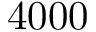Convert formula to latex. <formula><loc_0><loc_0><loc_500><loc_500>4 0 0 0</formula> 